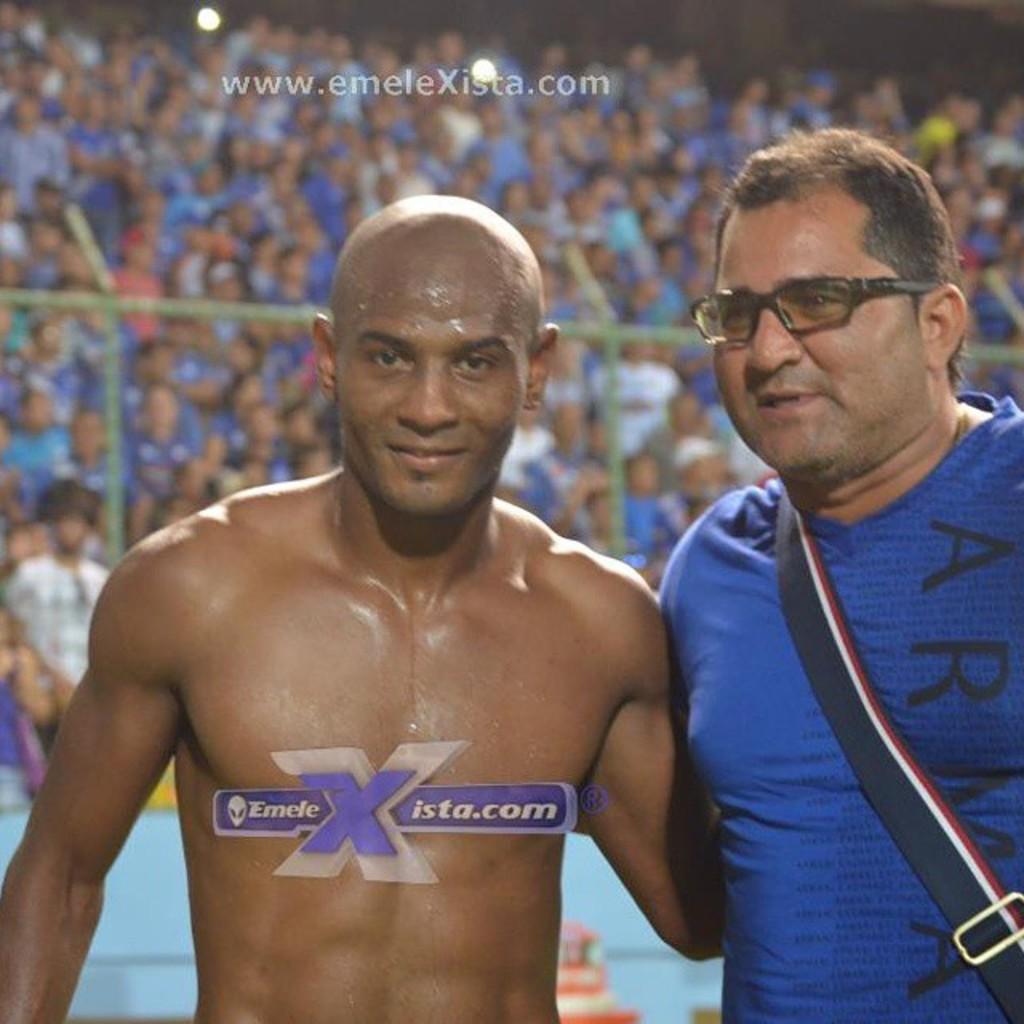<image>
Create a compact narrative representing the image presented. a boxer standing next to someone, the photo licensed to emelexista.com 